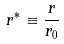Convert formula to latex. <formula><loc_0><loc_0><loc_500><loc_500>r ^ { * } \equiv \frac { r } { r _ { 0 } }</formula> 